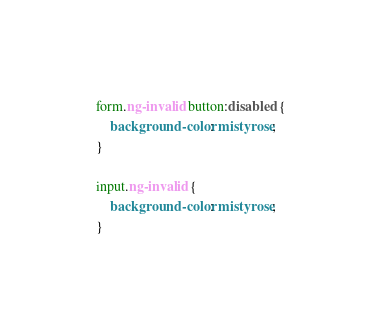<code> <loc_0><loc_0><loc_500><loc_500><_CSS_>form.ng-invalid button:disabled {
    background-color: mistyrose;
}

input.ng-invalid {
    background-color: mistyrose;
}
</code> 